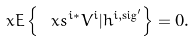Convert formula to latex. <formula><loc_0><loc_0><loc_500><loc_500>\ x E \left \{ \ x s ^ { i \ast } V ^ { i } | h ^ { i , \text {sig} ^ { \prime } } \right \} = 0 .</formula> 